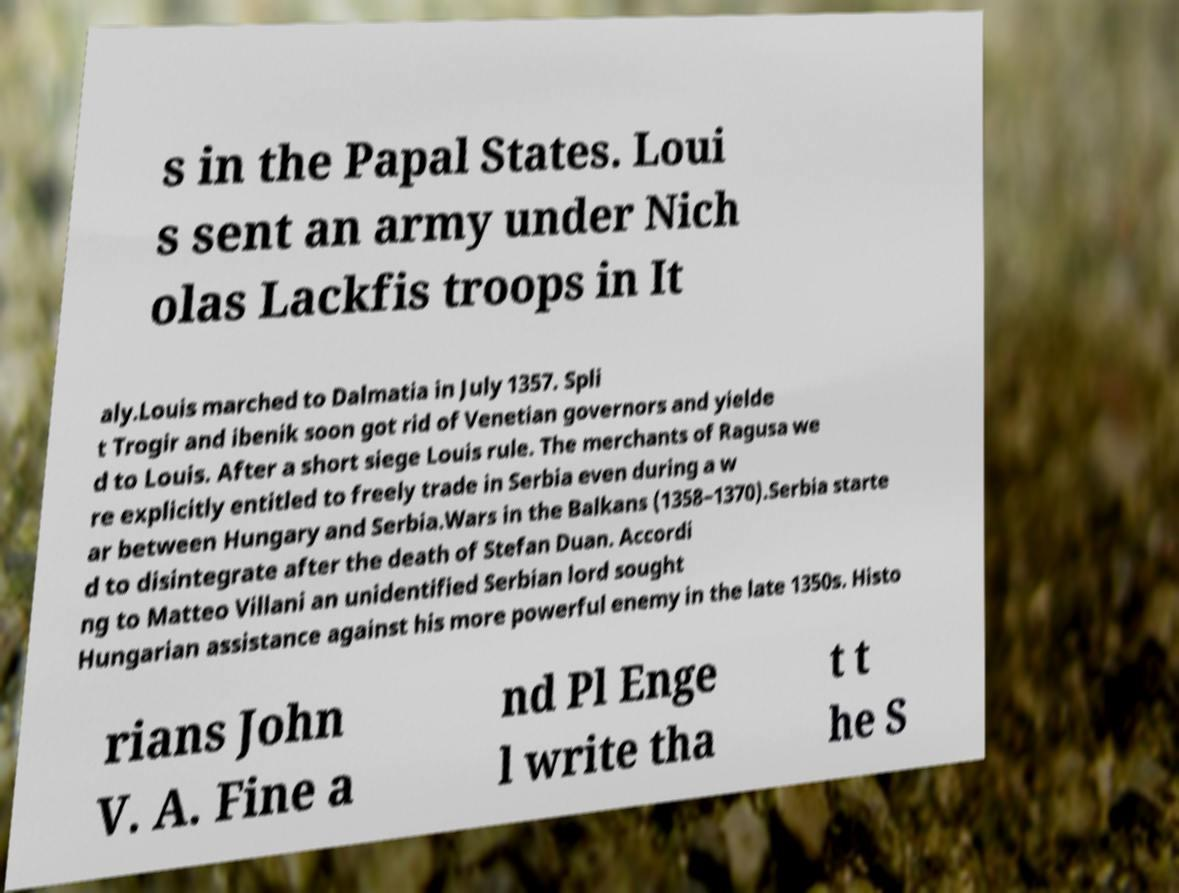What messages or text are displayed in this image? I need them in a readable, typed format. s in the Papal States. Loui s sent an army under Nich olas Lackfis troops in It aly.Louis marched to Dalmatia in July 1357. Spli t Trogir and ibenik soon got rid of Venetian governors and yielde d to Louis. After a short siege Louis rule. The merchants of Ragusa we re explicitly entitled to freely trade in Serbia even during a w ar between Hungary and Serbia.Wars in the Balkans (1358–1370).Serbia starte d to disintegrate after the death of Stefan Duan. Accordi ng to Matteo Villani an unidentified Serbian lord sought Hungarian assistance against his more powerful enemy in the late 1350s. Histo rians John V. A. Fine a nd Pl Enge l write tha t t he S 